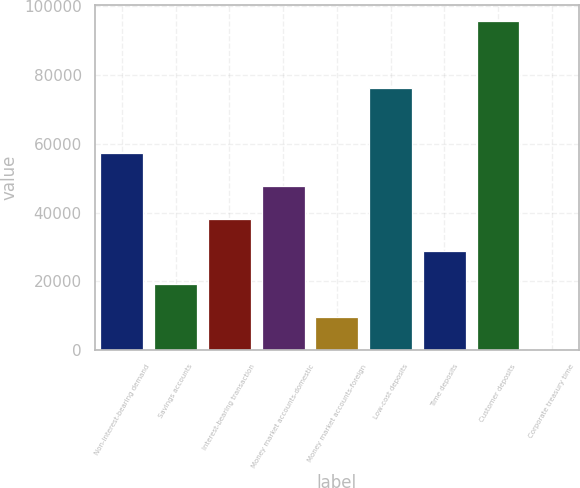Convert chart to OTSL. <chart><loc_0><loc_0><loc_500><loc_500><bar_chart><fcel>Non-interest-bearing demand<fcel>Savings accounts<fcel>Interest-bearing transaction<fcel>Money market accounts-domestic<fcel>Money market accounts-foreign<fcel>Low-cost deposits<fcel>Time deposits<fcel>Customer deposits<fcel>Corporate treasury time<nl><fcel>57375.2<fcel>19128.4<fcel>38251.8<fcel>47813.5<fcel>9566.7<fcel>76244<fcel>28690.1<fcel>95622<fcel>5<nl></chart> 